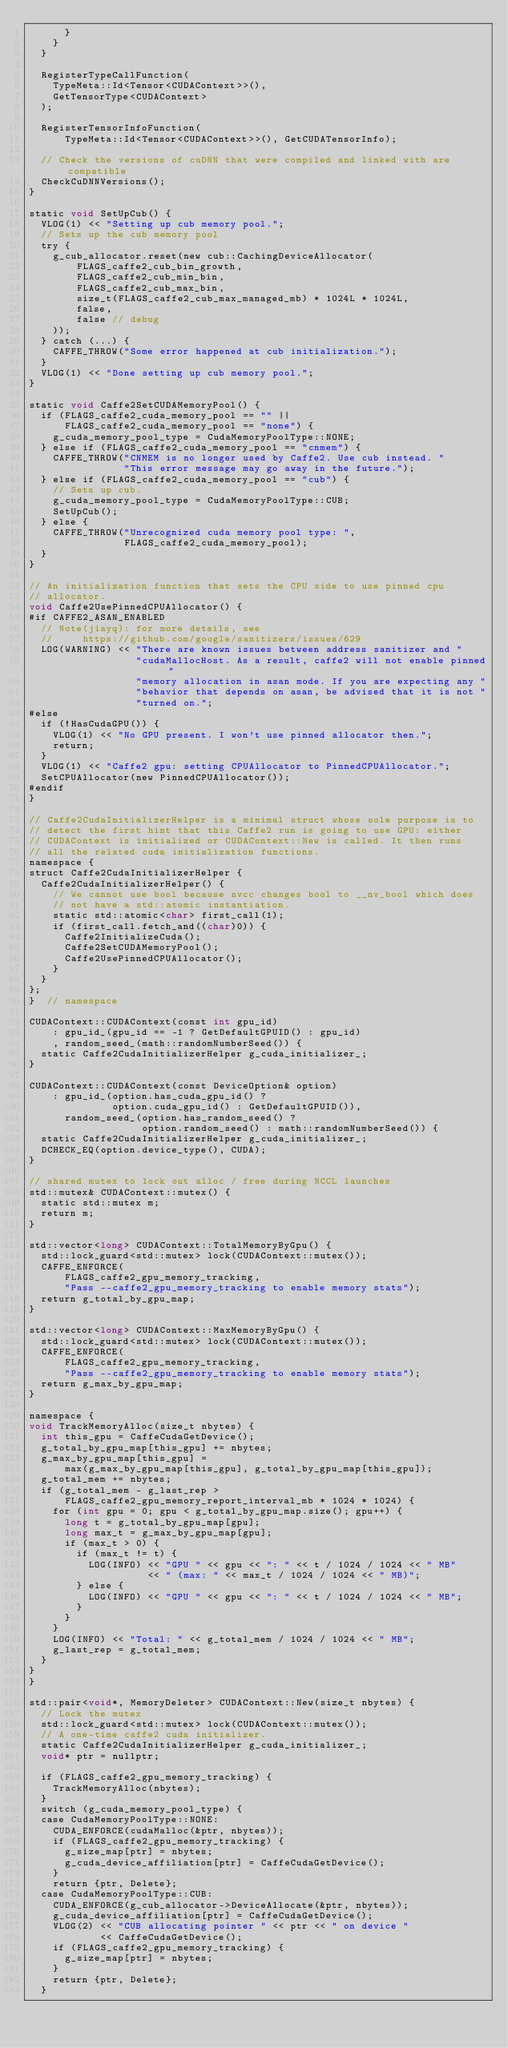Convert code to text. <code><loc_0><loc_0><loc_500><loc_500><_Cuda_>      }
    }
  }

  RegisterTypeCallFunction(
    TypeMeta::Id<Tensor<CUDAContext>>(),
    GetTensorType<CUDAContext>
  );

  RegisterTensorInfoFunction(
      TypeMeta::Id<Tensor<CUDAContext>>(), GetCUDATensorInfo);

  // Check the versions of cuDNN that were compiled and linked with are compatible
  CheckCuDNNVersions();
}

static void SetUpCub() {
  VLOG(1) << "Setting up cub memory pool.";
  // Sets up the cub memory pool
  try {
    g_cub_allocator.reset(new cub::CachingDeviceAllocator(
        FLAGS_caffe2_cub_bin_growth,
        FLAGS_caffe2_cub_min_bin,
        FLAGS_caffe2_cub_max_bin,
        size_t(FLAGS_caffe2_cub_max_managed_mb) * 1024L * 1024L,
        false,
        false // debug
    ));
  } catch (...) {
    CAFFE_THROW("Some error happened at cub initialization.");
  }
  VLOG(1) << "Done setting up cub memory pool.";
}

static void Caffe2SetCUDAMemoryPool() {
  if (FLAGS_caffe2_cuda_memory_pool == "" ||
      FLAGS_caffe2_cuda_memory_pool == "none") {
    g_cuda_memory_pool_type = CudaMemoryPoolType::NONE;
  } else if (FLAGS_caffe2_cuda_memory_pool == "cnmem") {
    CAFFE_THROW("CNMEM is no longer used by Caffe2. Use cub instead. "
                "This error message may go away in the future.");
  } else if (FLAGS_caffe2_cuda_memory_pool == "cub") {
    // Sets up cub.
    g_cuda_memory_pool_type = CudaMemoryPoolType::CUB;
    SetUpCub();
  } else {
    CAFFE_THROW("Unrecognized cuda memory pool type: ",
                FLAGS_caffe2_cuda_memory_pool);
  }
}

// An initialization function that sets the CPU side to use pinned cpu
// allocator.
void Caffe2UsePinnedCPUAllocator() {
#if CAFFE2_ASAN_ENABLED
  // Note(jiayq): for more details, see
  //     https://github.com/google/sanitizers/issues/629
  LOG(WARNING) << "There are known issues between address sanitizer and "
                  "cudaMallocHost. As a result, caffe2 will not enable pinned "
                  "memory allocation in asan mode. If you are expecting any "
                  "behavior that depends on asan, be advised that it is not "
                  "turned on.";
#else
  if (!HasCudaGPU()) {
    VLOG(1) << "No GPU present. I won't use pinned allocator then.";
    return;
  }
  VLOG(1) << "Caffe2 gpu: setting CPUAllocator to PinnedCPUAllocator.";
  SetCPUAllocator(new PinnedCPUAllocator());
#endif
}

// Caffe2CudaInitializerHelper is a minimal struct whose sole purpose is to
// detect the first hint that this Caffe2 run is going to use GPU: either
// CUDAContext is initialized or CUDAContext::New is called. It then runs
// all the related cuda initialization functions.
namespace {
struct Caffe2CudaInitializerHelper {
  Caffe2CudaInitializerHelper() {
    // We cannot use bool because nvcc changes bool to __nv_bool which does
    // not have a std::atomic instantiation.
    static std::atomic<char> first_call(1);
    if (first_call.fetch_and((char)0)) {
      Caffe2InitializeCuda();
      Caffe2SetCUDAMemoryPool();
      Caffe2UsePinnedCPUAllocator();
    }
  }
};
}  // namespace

CUDAContext::CUDAContext(const int gpu_id)
    : gpu_id_(gpu_id == -1 ? GetDefaultGPUID() : gpu_id)
    , random_seed_(math::randomNumberSeed()) {
  static Caffe2CudaInitializerHelper g_cuda_initializer_;
}

CUDAContext::CUDAContext(const DeviceOption& option)
    : gpu_id_(option.has_cuda_gpu_id() ?
              option.cuda_gpu_id() : GetDefaultGPUID()),
      random_seed_(option.has_random_seed() ?
                   option.random_seed() : math::randomNumberSeed()) {
  static Caffe2CudaInitializerHelper g_cuda_initializer_;
  DCHECK_EQ(option.device_type(), CUDA);
}

// shared mutex to lock out alloc / free during NCCL launches
std::mutex& CUDAContext::mutex() {
  static std::mutex m;
  return m;
}

std::vector<long> CUDAContext::TotalMemoryByGpu() {
  std::lock_guard<std::mutex> lock(CUDAContext::mutex());
  CAFFE_ENFORCE(
      FLAGS_caffe2_gpu_memory_tracking,
      "Pass --caffe2_gpu_memory_tracking to enable memory stats");
  return g_total_by_gpu_map;
}

std::vector<long> CUDAContext::MaxMemoryByGpu() {
  std::lock_guard<std::mutex> lock(CUDAContext::mutex());
  CAFFE_ENFORCE(
      FLAGS_caffe2_gpu_memory_tracking,
      "Pass --caffe2_gpu_memory_tracking to enable memory stats");
  return g_max_by_gpu_map;
}

namespace {
void TrackMemoryAlloc(size_t nbytes) {
  int this_gpu = CaffeCudaGetDevice();
  g_total_by_gpu_map[this_gpu] += nbytes;
  g_max_by_gpu_map[this_gpu] =
      max(g_max_by_gpu_map[this_gpu], g_total_by_gpu_map[this_gpu]);
  g_total_mem += nbytes;
  if (g_total_mem - g_last_rep >
      FLAGS_caffe2_gpu_memory_report_interval_mb * 1024 * 1024) {
    for (int gpu = 0; gpu < g_total_by_gpu_map.size(); gpu++) {
      long t = g_total_by_gpu_map[gpu];
      long max_t = g_max_by_gpu_map[gpu];
      if (max_t > 0) {
        if (max_t != t) {
          LOG(INFO) << "GPU " << gpu << ": " << t / 1024 / 1024 << " MB"
                    << " (max: " << max_t / 1024 / 1024 << " MB)";
        } else {
          LOG(INFO) << "GPU " << gpu << ": " << t / 1024 / 1024 << " MB";
        }
      }
    }
    LOG(INFO) << "Total: " << g_total_mem / 1024 / 1024 << " MB";
    g_last_rep = g_total_mem;
  }
}
}

std::pair<void*, MemoryDeleter> CUDAContext::New(size_t nbytes) {
  // Lock the mutex
  std::lock_guard<std::mutex> lock(CUDAContext::mutex());
  // A one-time caffe2 cuda initializer.
  static Caffe2CudaInitializerHelper g_cuda_initializer_;
  void* ptr = nullptr;

  if (FLAGS_caffe2_gpu_memory_tracking) {
    TrackMemoryAlloc(nbytes);
  }
  switch (g_cuda_memory_pool_type) {
  case CudaMemoryPoolType::NONE:
    CUDA_ENFORCE(cudaMalloc(&ptr, nbytes));
    if (FLAGS_caffe2_gpu_memory_tracking) {
      g_size_map[ptr] = nbytes;
      g_cuda_device_affiliation[ptr] = CaffeCudaGetDevice();
    }
    return {ptr, Delete};
  case CudaMemoryPoolType::CUB:
    CUDA_ENFORCE(g_cub_allocator->DeviceAllocate(&ptr, nbytes));
    g_cuda_device_affiliation[ptr] = CaffeCudaGetDevice();
    VLOG(2) << "CUB allocating pointer " << ptr << " on device "
            << CaffeCudaGetDevice();
    if (FLAGS_caffe2_gpu_memory_tracking) {
      g_size_map[ptr] = nbytes;
    }
    return {ptr, Delete};
  }</code> 